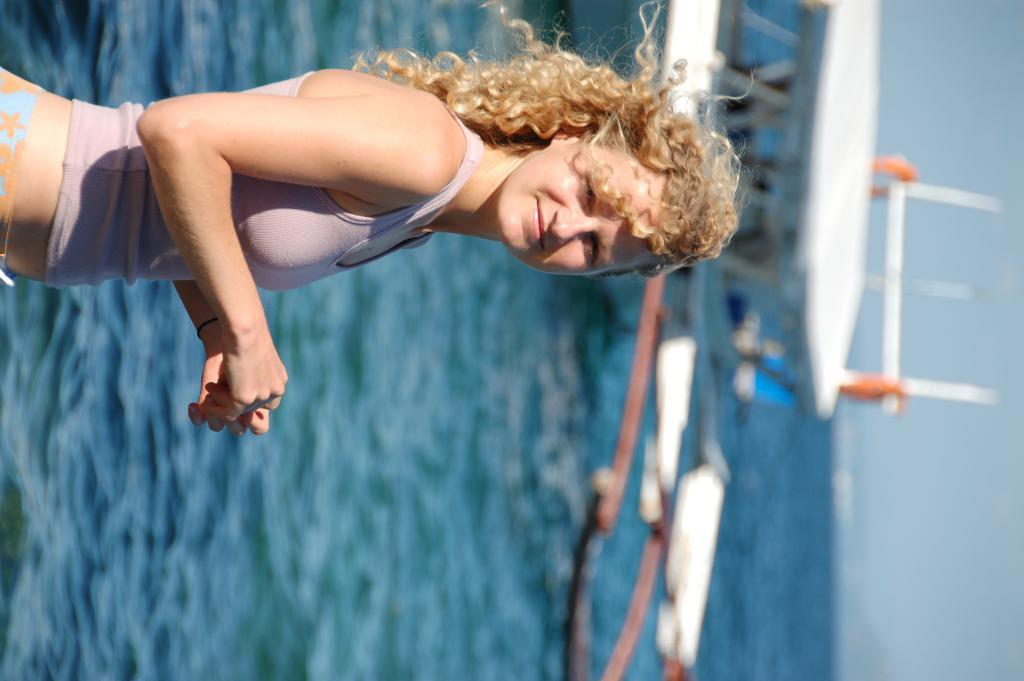What is the main subject of the image? There is a person standing in the image. What can be seen in the background of the image? There is a ship visible on the water in the background. What is the color of the sky in the image? The sky is blue in color. Where is the plate with the rabbit on it located in the image? There is no plate or rabbit present in the image. What type of attraction can be seen in the image? There is no attraction visible in the image; it features a person standing and a ship in the background. 